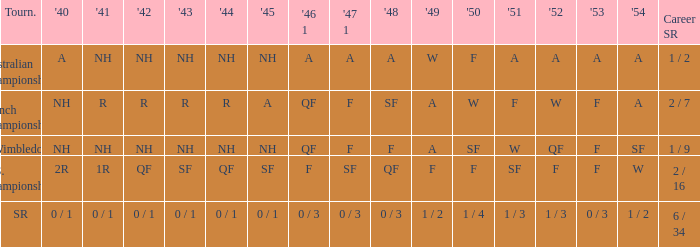What is the 1944 result for the U.S. Championships? QF. 